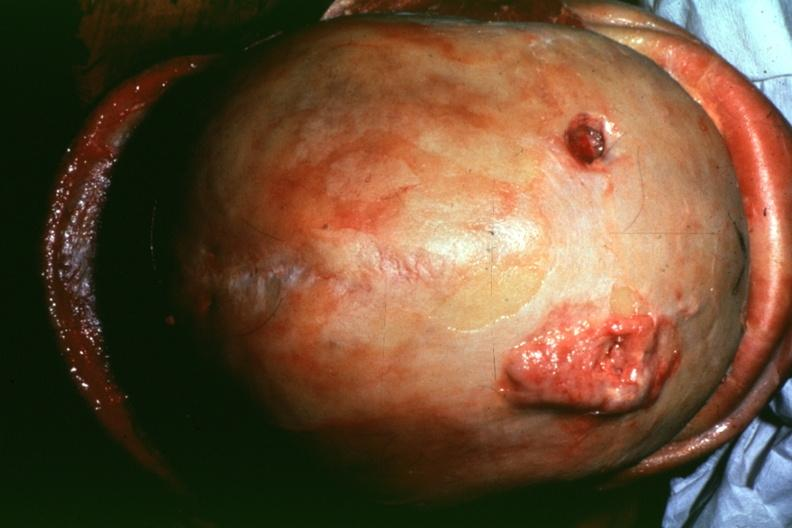what is present?
Answer the question using a single word or phrase. Bone 